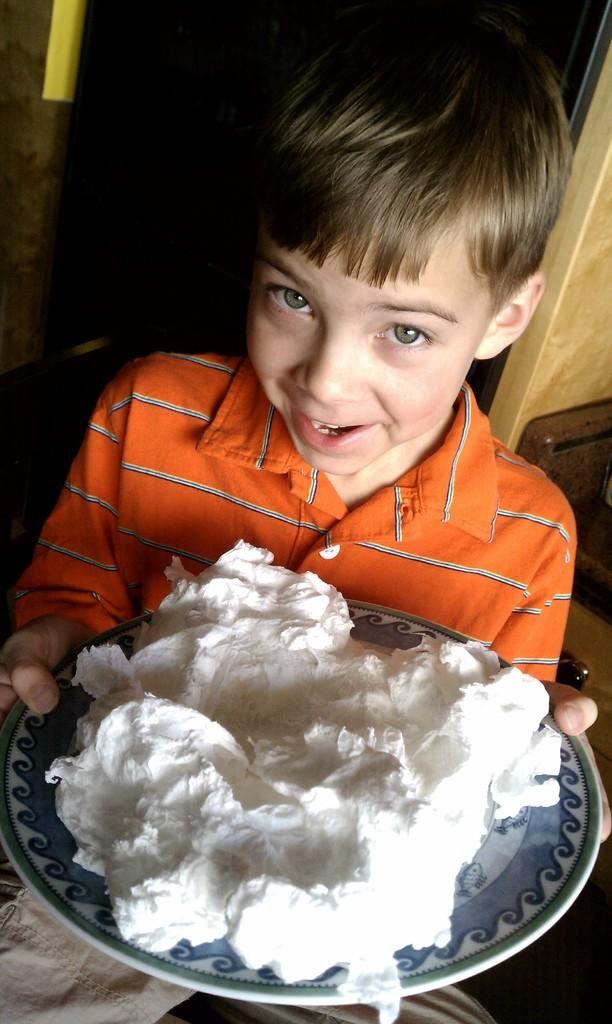Who is the main subject in the image? There is a boy in the image. What is the boy holding in his hand? The boy is holding a plate with his hand. What expression does the boy have on his face? The boy is smiling. What is on the plate that the boy is holding? There is white cream on the plate. What can be observed about the background of the image? The background of the image is dark. What type of pan can be seen in the image? There is no pan present in the image. Can you tell me how many letters are on the tiger's back in the image? There is no tiger present in the image, and therefore no letters on its back. 